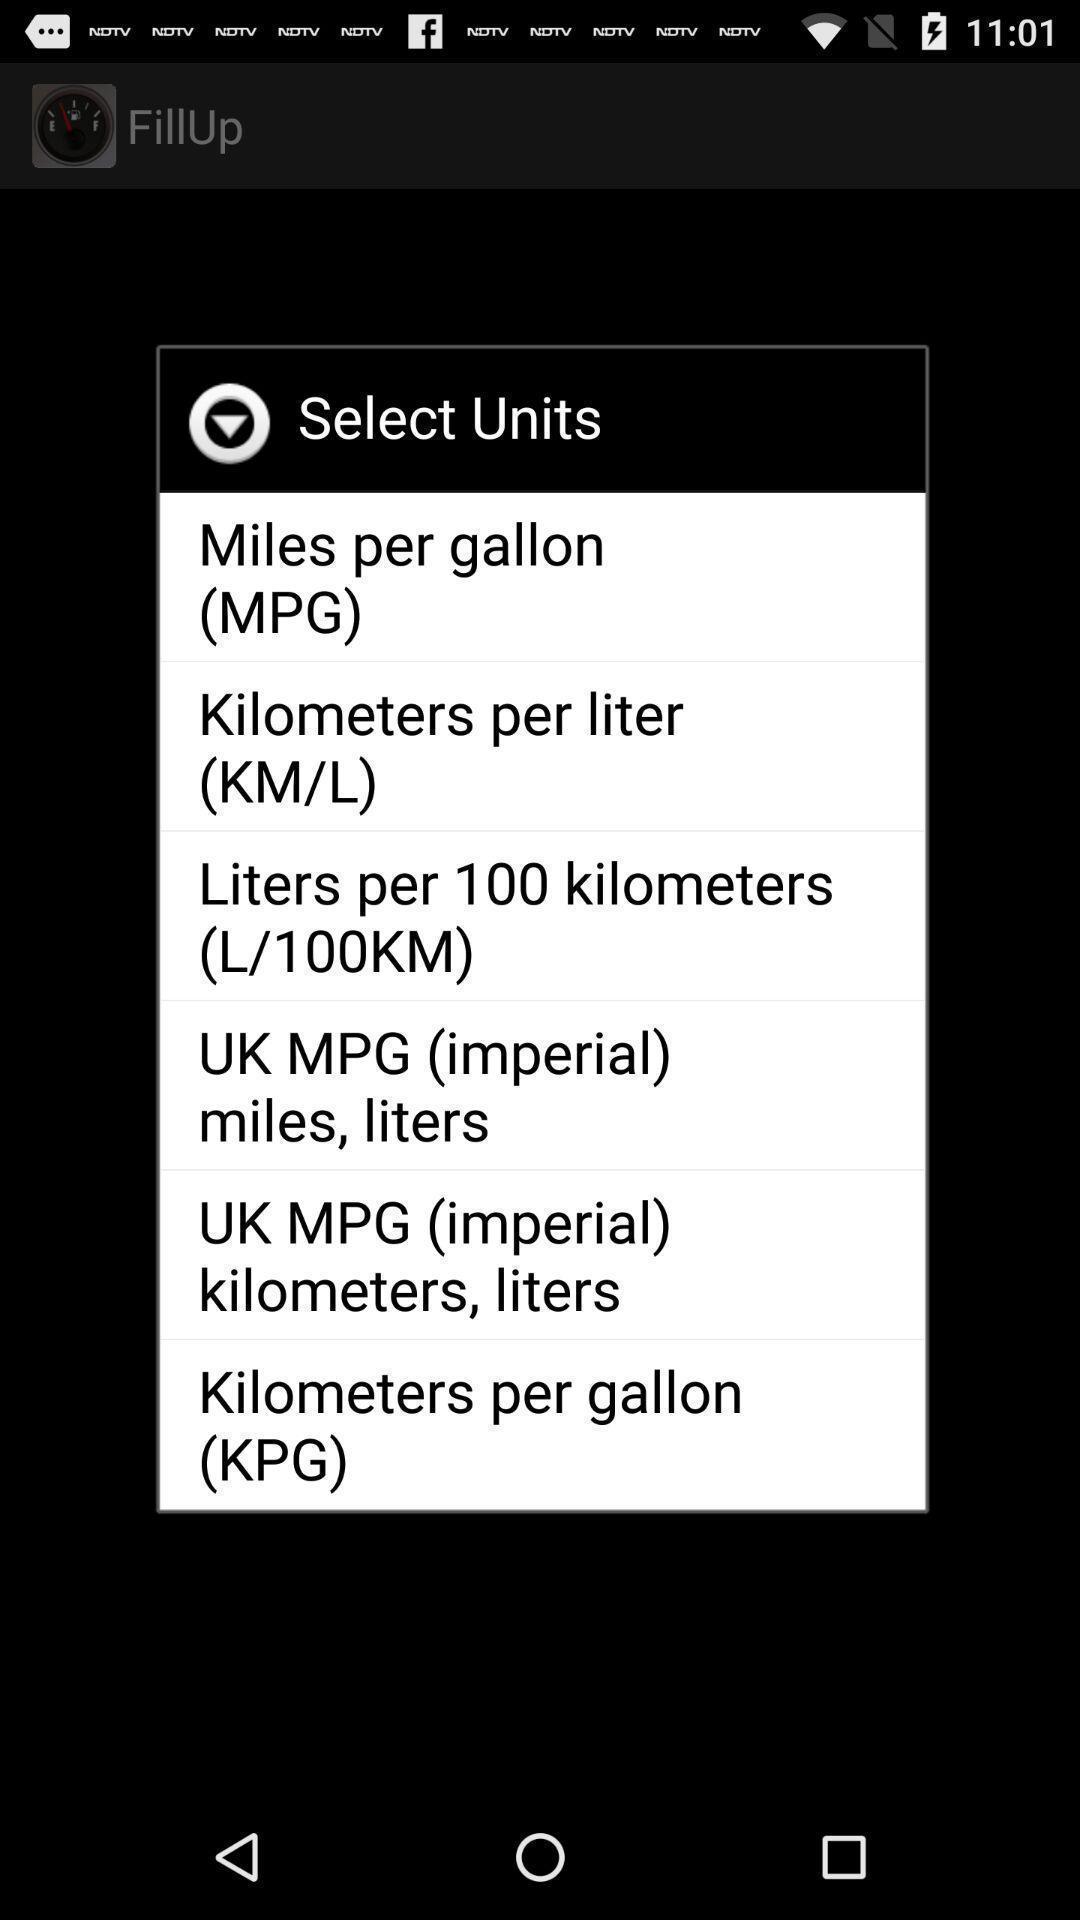Provide a textual representation of this image. Popup showing different units in gas tracking app. 